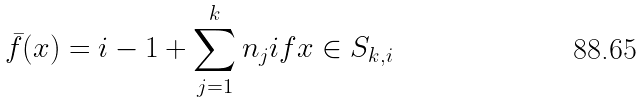<formula> <loc_0><loc_0><loc_500><loc_500>\bar { f } ( x ) = i - 1 + \sum _ { j = 1 } ^ { k } n _ { j } i f x \in S _ { k , i }</formula> 